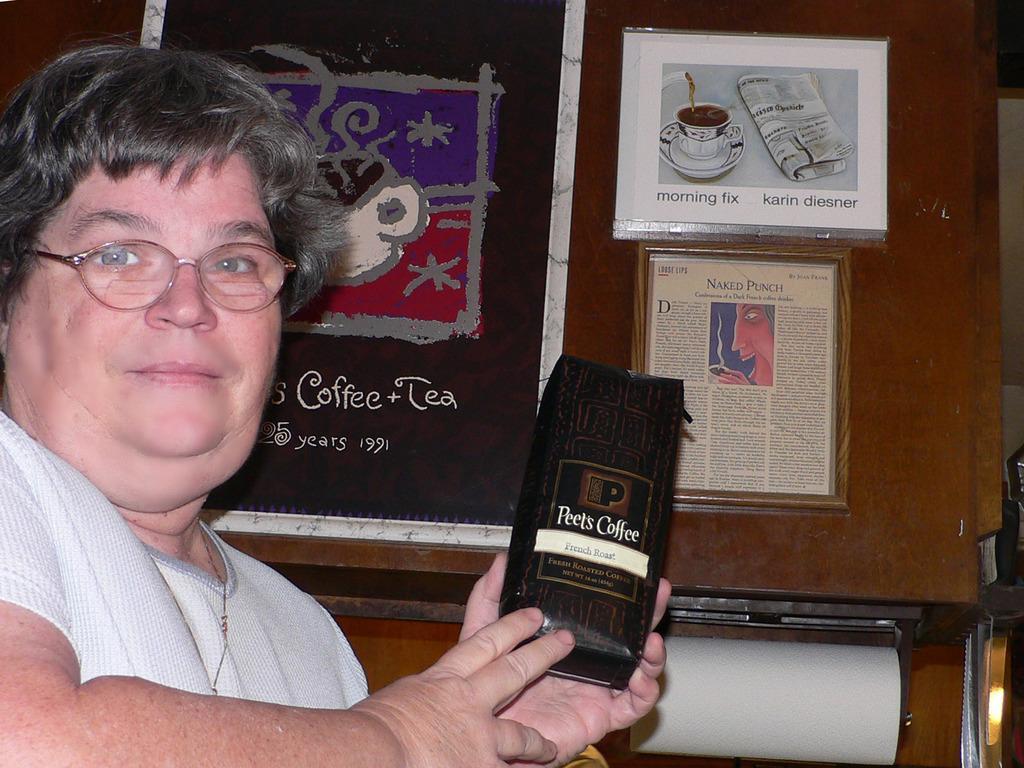In one or two sentences, can you explain what this image depicts? In this image there is a women holding a packet in her and wearing glasses, in the background there is a wall for that wall there are posters, on that posters there is some text. 